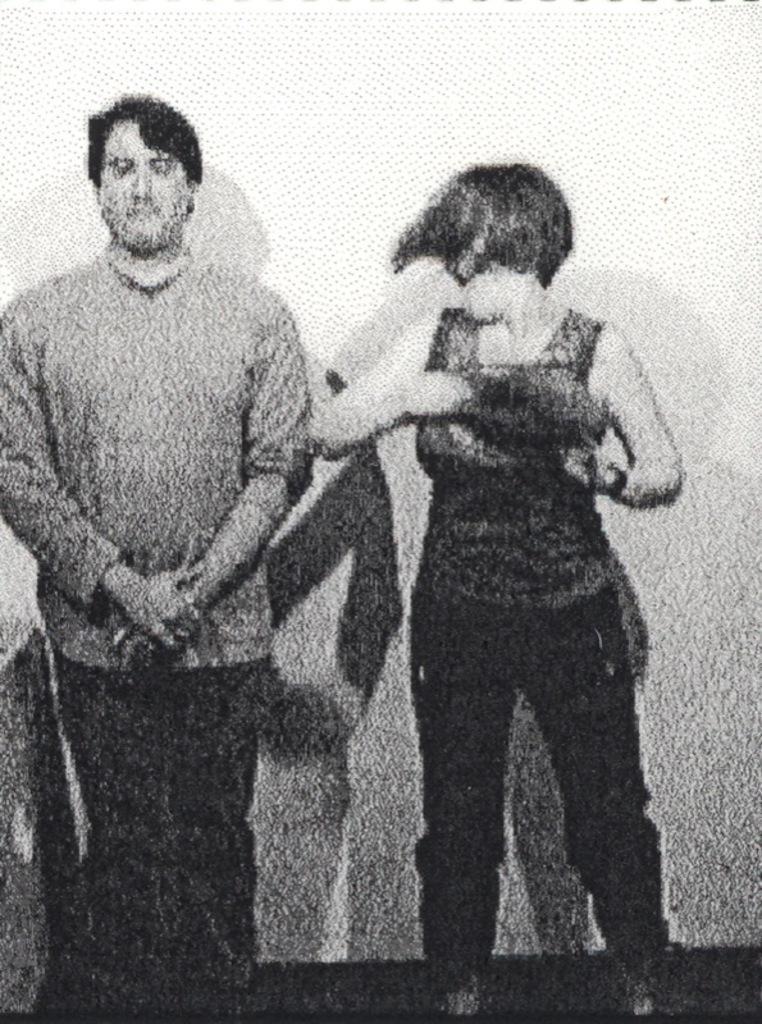Could you give a brief overview of what you see in this image? This is a blurred image, we can see a man and a woman standing. 